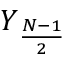Convert formula to latex. <formula><loc_0><loc_0><loc_500><loc_500>Y _ { \frac { N - 1 } { 2 } }</formula> 